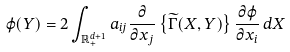Convert formula to latex. <formula><loc_0><loc_0><loc_500><loc_500>\varphi ( Y ) = 2 \int _ { \mathbb { R } ^ { d + 1 } _ { + } } a _ { i j } \frac { \partial } { \partial x _ { j } } \left \{ \widetilde { \Gamma } ( X , Y ) \right \} \frac { \partial \varphi } { \partial x _ { i } } \, d X</formula> 